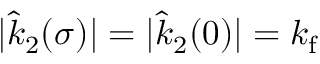Convert formula to latex. <formula><loc_0><loc_0><loc_500><loc_500>| \hat { k } _ { 2 } ( \sigma ) | = | \hat { k } _ { 2 } ( 0 ) | = k _ { f }</formula> 